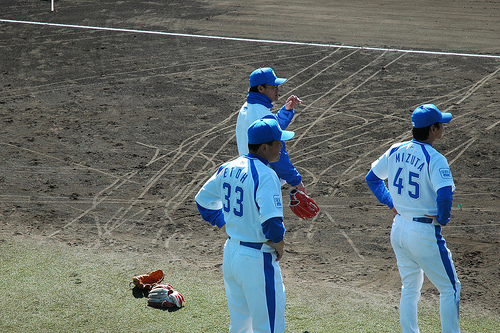<image>
Is there a player in front of the glove? Yes. The player is positioned in front of the glove, appearing closer to the camera viewpoint. 